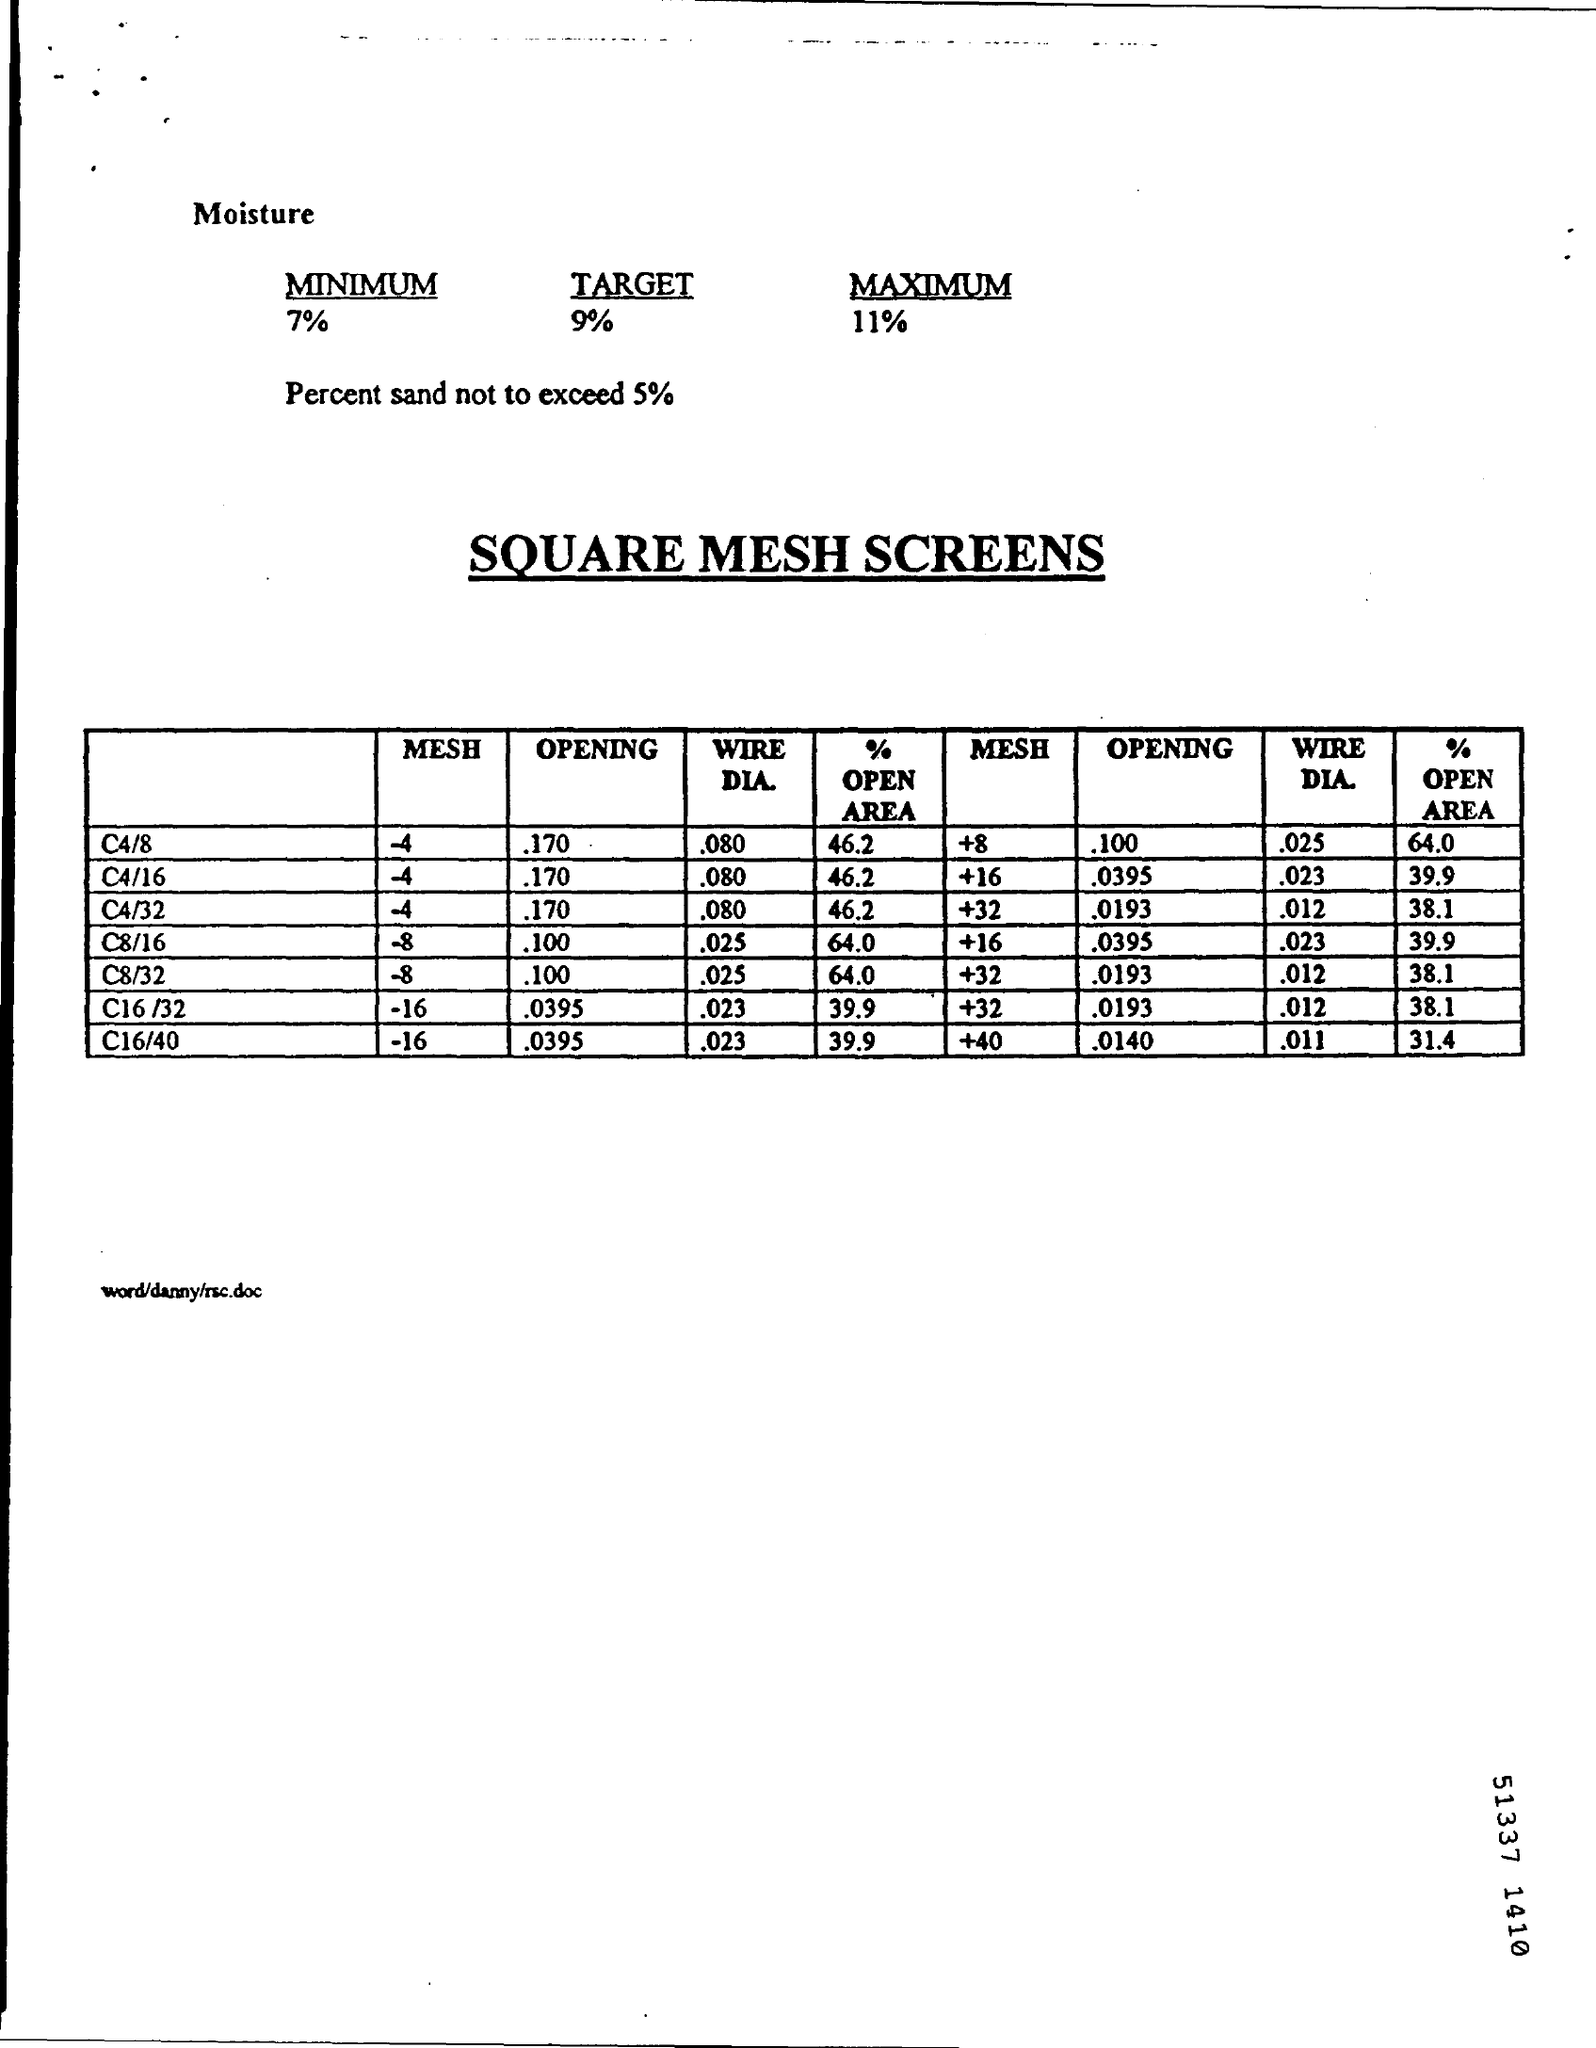Highlight a few significant elements in this photo. The opening of C4/8 of a mesh with an index of -4 is approximately 0.170. The maximum percentage of sand that can be used is 5%. The target moisture level is 9%. The heading of the table reads "SQUARE MESH SCREENS.. 